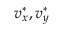<formula> <loc_0><loc_0><loc_500><loc_500>v _ { x } ^ { \ast } , v _ { y } ^ { \ast }</formula> 